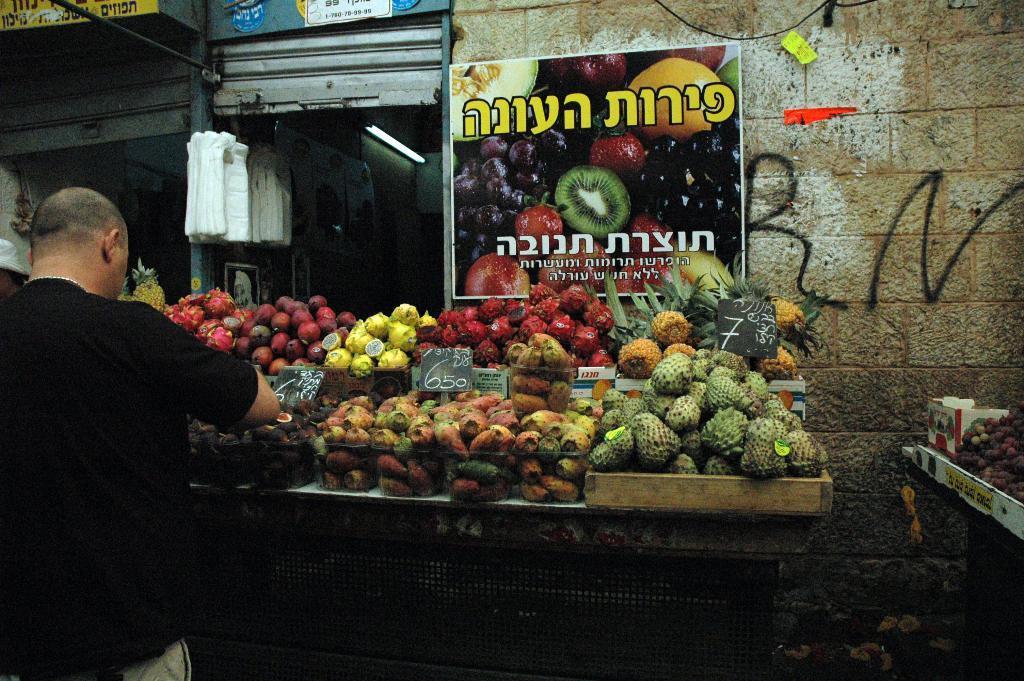Describe this image in one or two sentences. In this picture we can observe some fruit stalls. We can observe different types of fruits placed in the boxes. There is poster on the wall. The wall is in cream and white color. In front of the stall we can observe a man standing. On the left side there are white color covers and a shutter. 